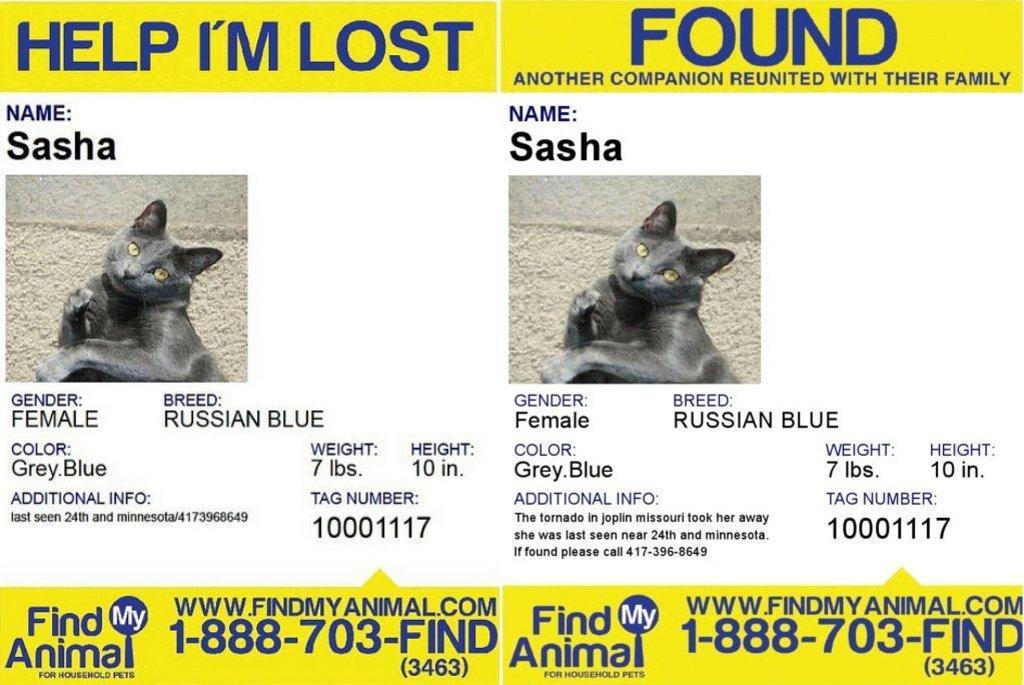In one or two sentences, can you explain what this image depicts? Here in this picture we can see posters present and we can see a cat picture on it and we can see some text written on it over there. 